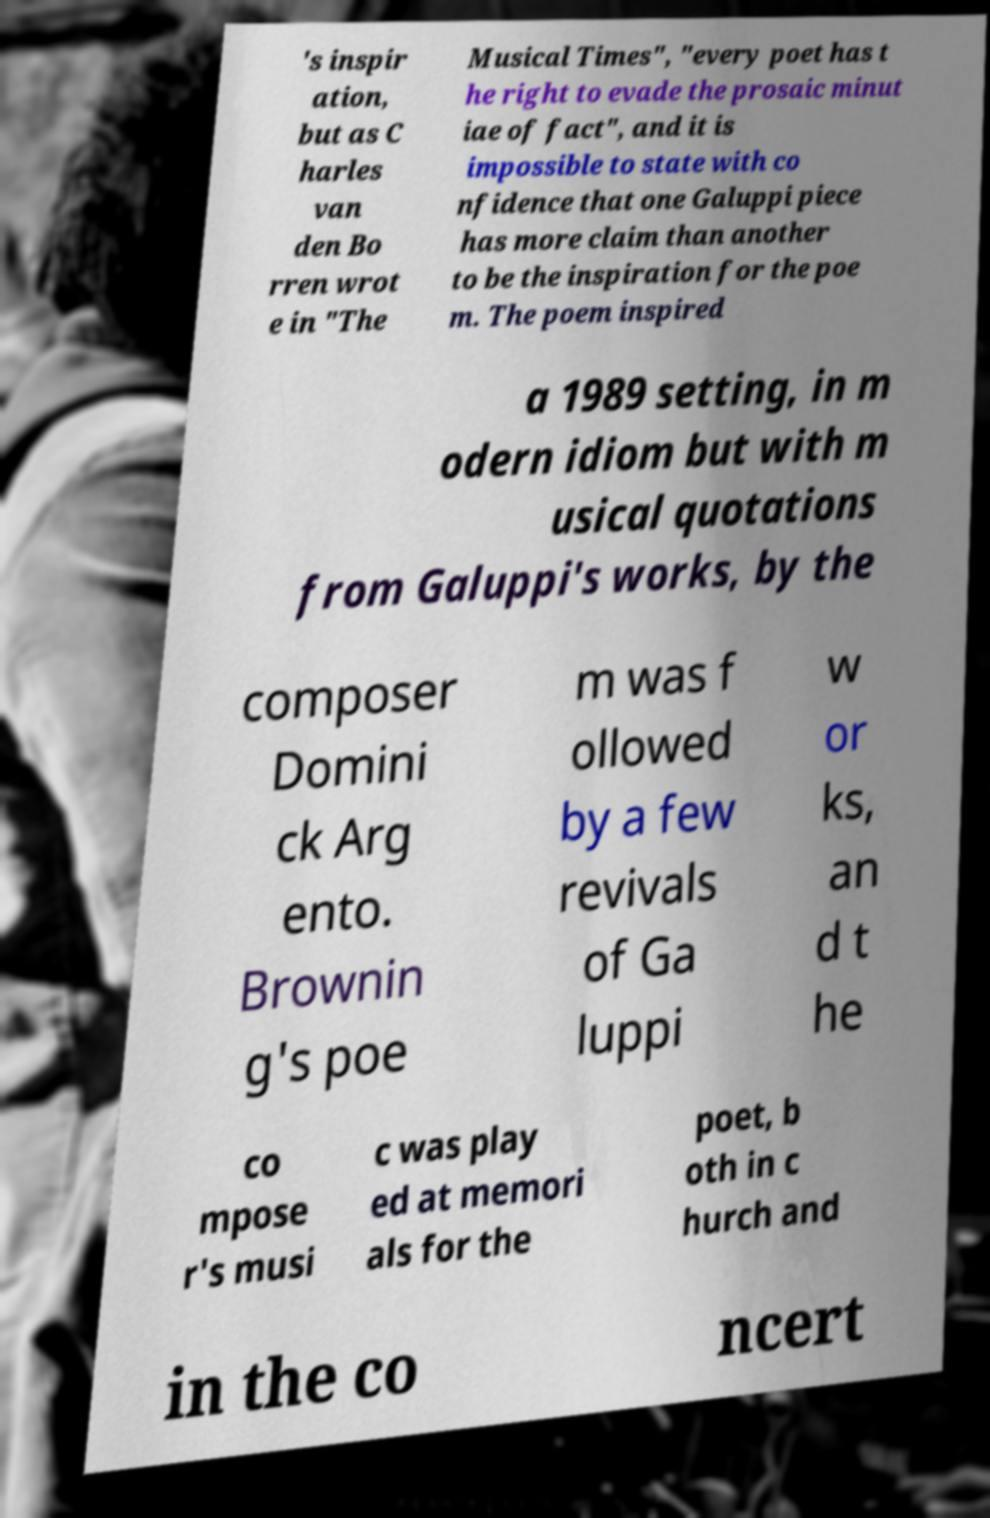There's text embedded in this image that I need extracted. Can you transcribe it verbatim? 's inspir ation, but as C harles van den Bo rren wrot e in "The Musical Times", "every poet has t he right to evade the prosaic minut iae of fact", and it is impossible to state with co nfidence that one Galuppi piece has more claim than another to be the inspiration for the poe m. The poem inspired a 1989 setting, in m odern idiom but with m usical quotations from Galuppi's works, by the composer Domini ck Arg ento. Brownin g's poe m was f ollowed by a few revivals of Ga luppi w or ks, an d t he co mpose r's musi c was play ed at memori als for the poet, b oth in c hurch and in the co ncert 